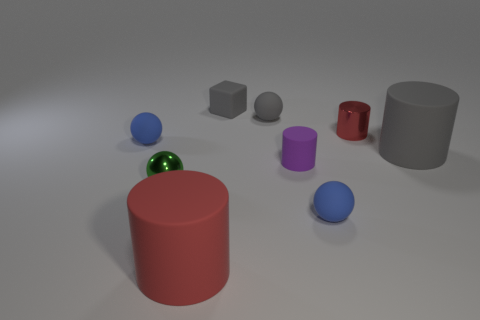Subtract all rubber cylinders. How many cylinders are left? 1 Subtract all blocks. How many objects are left? 8 Subtract all green balls. How many balls are left? 3 Add 5 tiny rubber cylinders. How many tiny rubber cylinders are left? 6 Add 4 tiny rubber spheres. How many tiny rubber spheres exist? 7 Add 1 small blue things. How many objects exist? 10 Subtract 0 yellow spheres. How many objects are left? 9 Subtract 3 cylinders. How many cylinders are left? 1 Subtract all brown cylinders. Subtract all blue balls. How many cylinders are left? 4 Subtract all cyan cylinders. How many gray balls are left? 1 